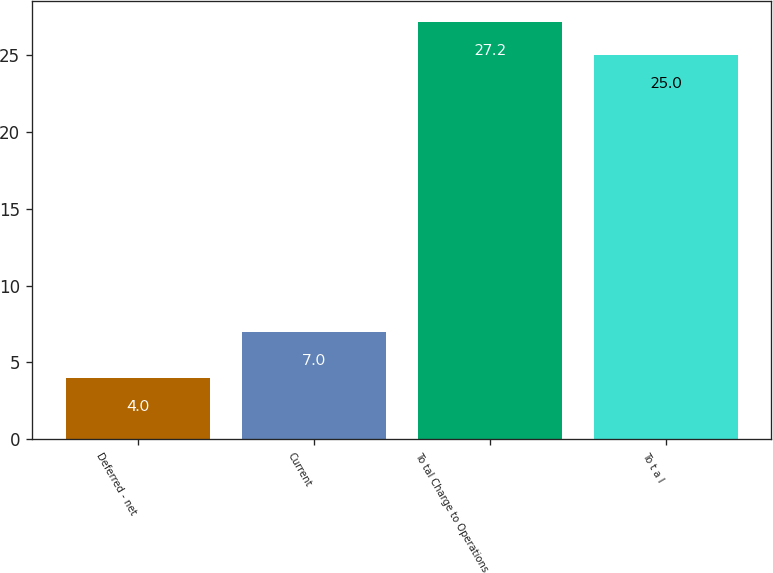Convert chart. <chart><loc_0><loc_0><loc_500><loc_500><bar_chart><fcel>Deferred - net<fcel>Current<fcel>To tal Charge to Operations<fcel>To t a l<nl><fcel>4<fcel>7<fcel>27.2<fcel>25<nl></chart> 